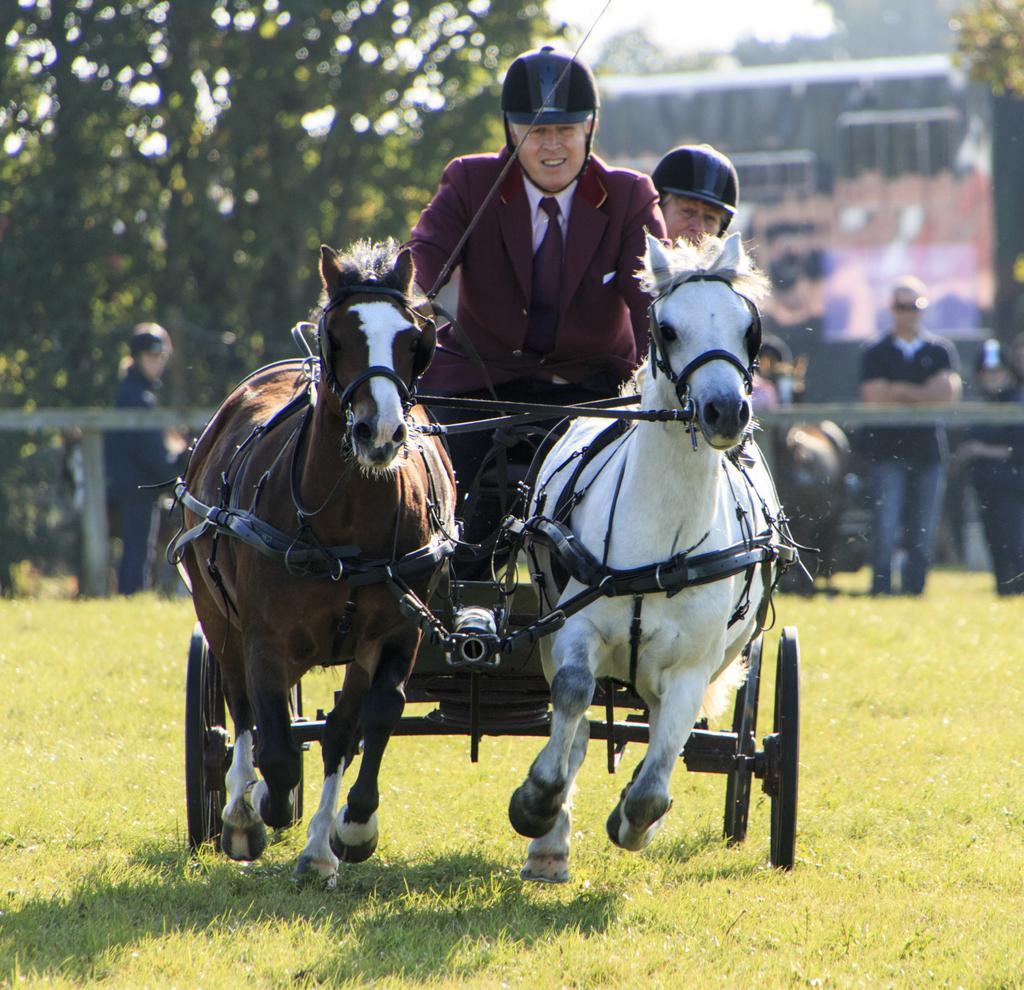Could you give a brief overview of what you see in this image? This image is clicked outside. There are two horses and two persons are riding those two horses. Both of them are wearing helmets. One horse is in brown color, other in white. There is tree on the left side and there is a building on the top. There are people who are watching them, they are standing behind horses. There is a Grass in the bottom. 